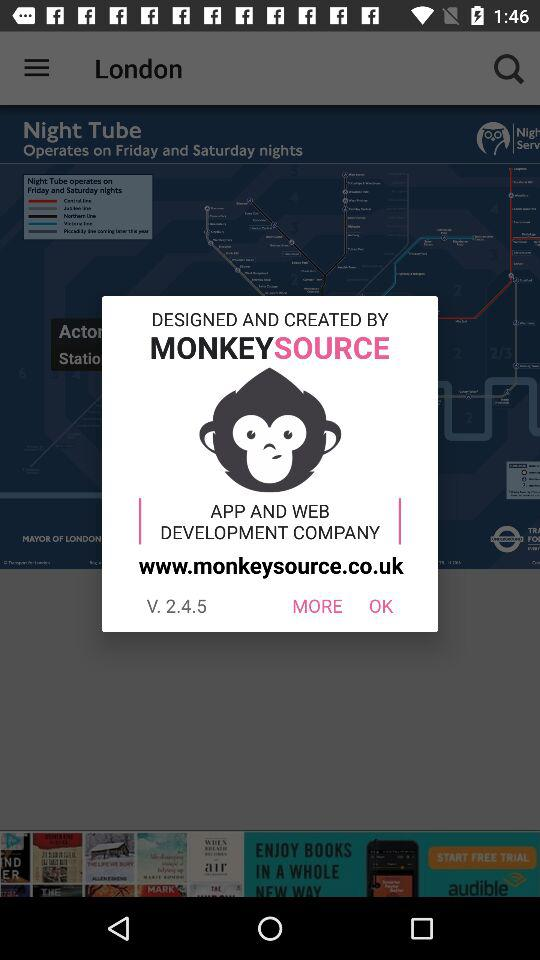What is the website? The website is www.monkeysource.co.uk. 